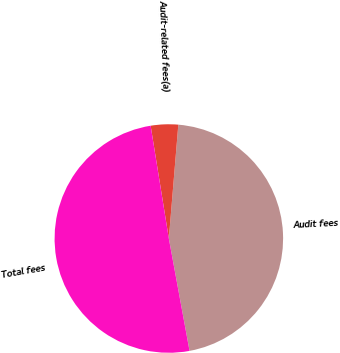<chart> <loc_0><loc_0><loc_500><loc_500><pie_chart><fcel>Audit fees<fcel>Audit-related fees(a)<fcel>Total fees<nl><fcel>45.77%<fcel>3.87%<fcel>50.35%<nl></chart> 